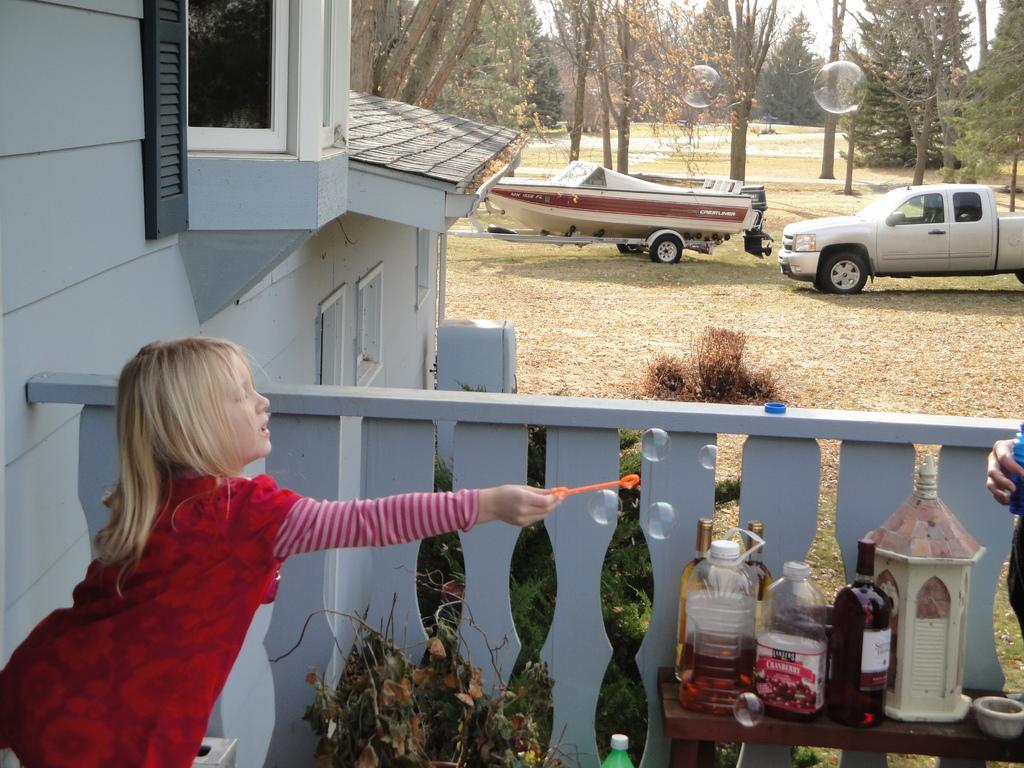Describe this image in one or two sentences. In this image i can see a girl and a table with a couple of objects on it. I can also see a vehicles on the ground and few trees. 